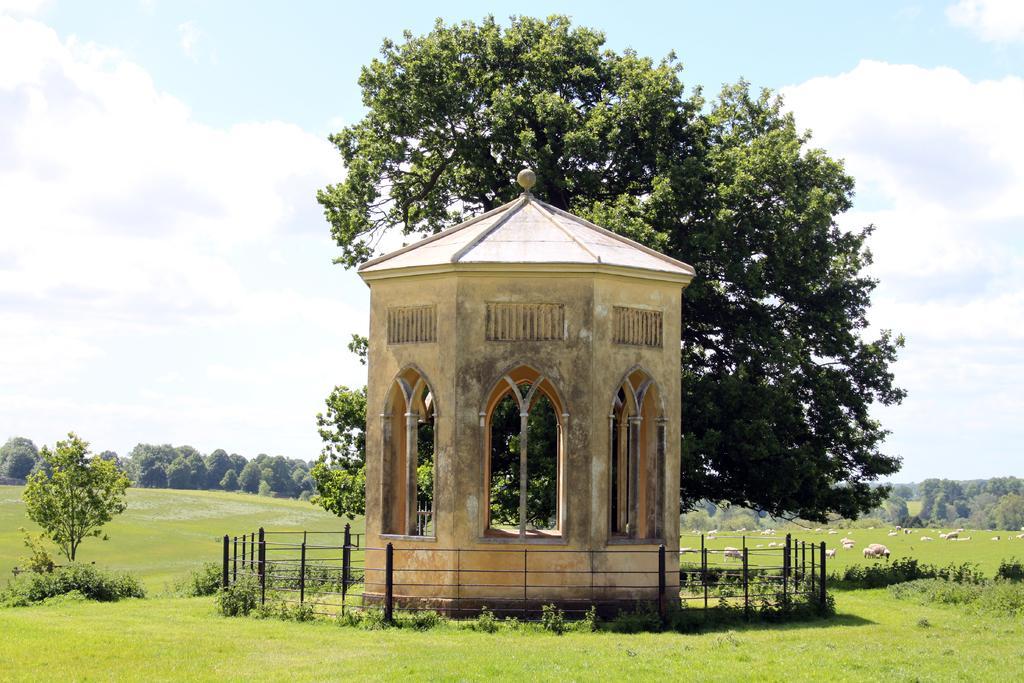How would you summarize this image in a sentence or two? In this picture there are trees in the left and right corner. There are animals and trees in the foreground, It looks like a building in the foreground. The grass is at the bottom. And the sky is at the top. 